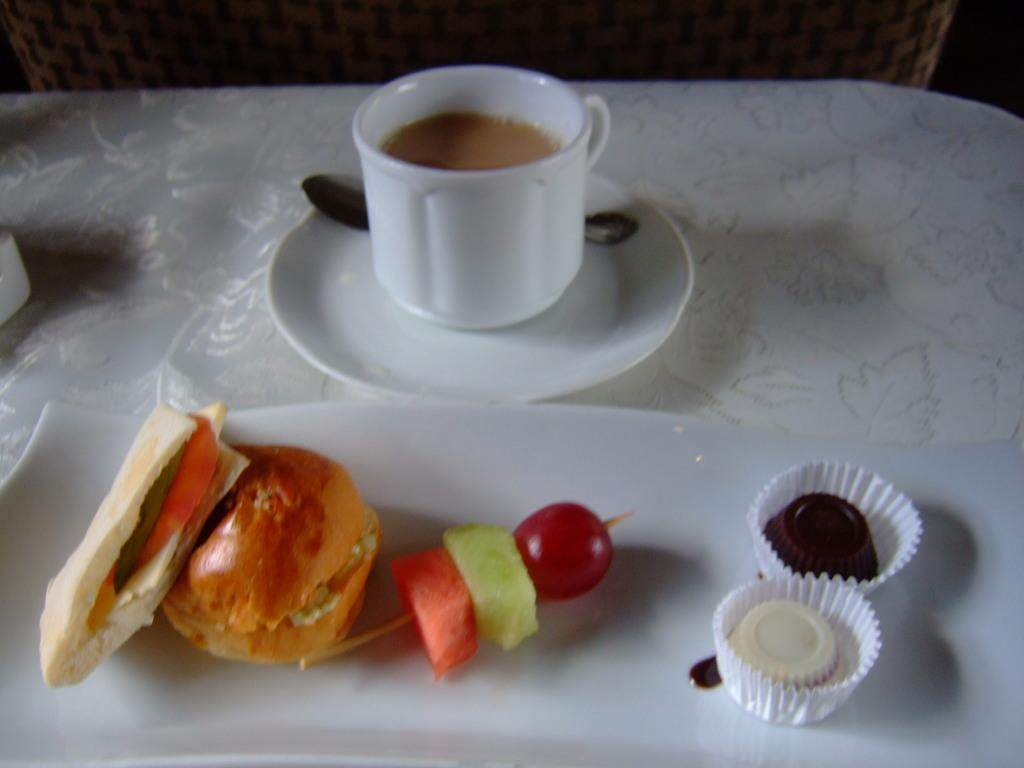What is in the cup that is visible in the image? There is a cup with tea in the image. What other items can be seen on the table in the image? There are food items on a plate and a saucer in the image. What utensil is present in the image? There is a spoon in the image. What might be used for covering or wiping in the image? There is a cloth in the image for covering or wiping. Can you describe the unspecified objects in the image? Unfortunately, the facts provided do not specify the nature of the unspecified objects in the image. What type of body is visible in the image? There is no body present in the image; it features a cup of tea, food items, a saucer, a spoon, and a cloth. 